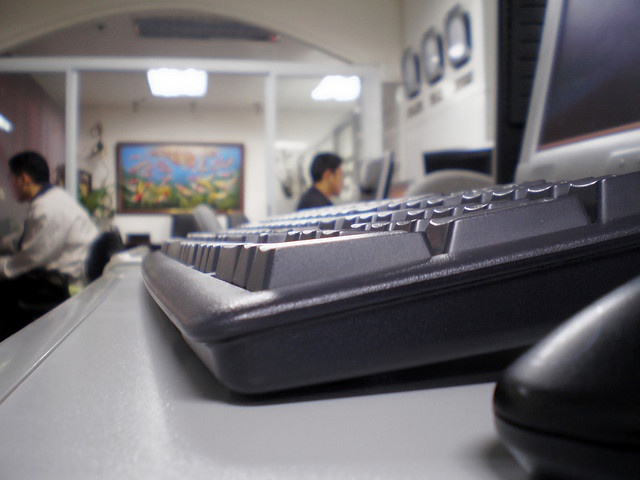Describe the objects in this image and their specific colors. I can see keyboard in gray, black, and darkgray tones, mouse in gray, black, darkgray, and lightgray tones, people in gray, black, darkgray, and lightgray tones, people in gray and black tones, and chair in gray, black, and darkgray tones in this image. 